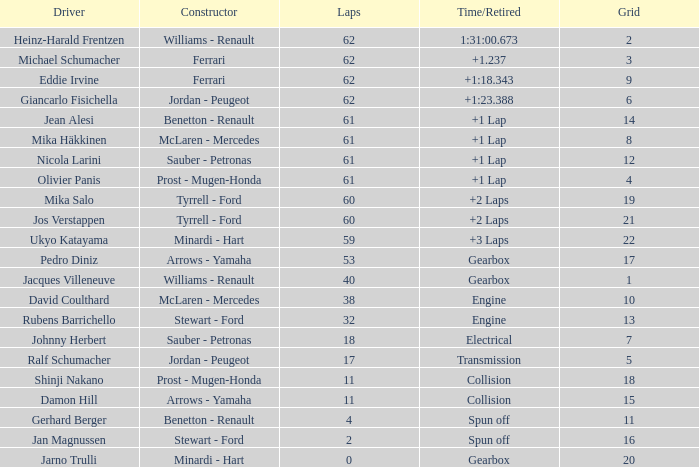What is the average number of laps that has a Time/Retired of +1 lap, a Driver of olivier panis, and a Grid larger than 4? None. 